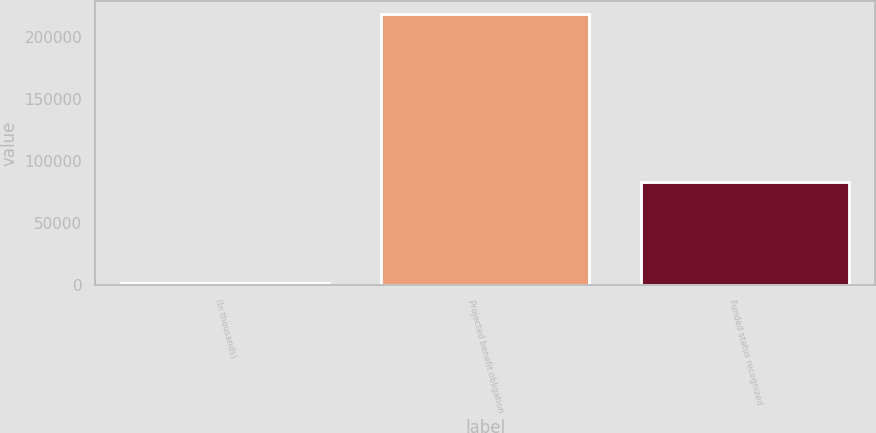Convert chart to OTSL. <chart><loc_0><loc_0><loc_500><loc_500><bar_chart><fcel>(In thousands)<fcel>Projected benefit obligation<fcel>Funded status recognized<nl><fcel>2015<fcel>218189<fcel>82940<nl></chart> 